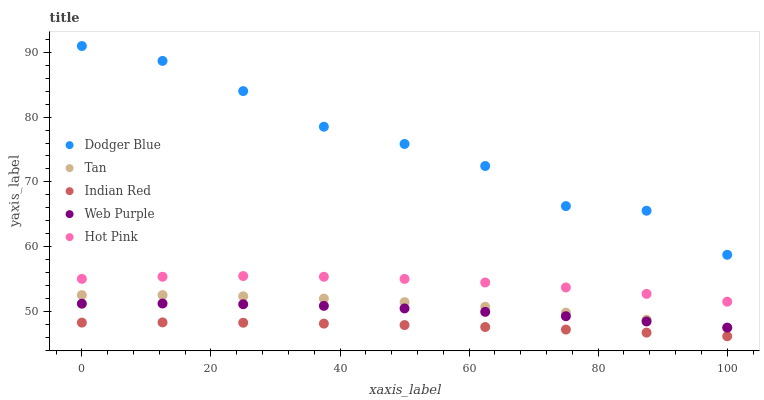Does Indian Red have the minimum area under the curve?
Answer yes or no. Yes. Does Dodger Blue have the maximum area under the curve?
Answer yes or no. Yes. Does Hot Pink have the minimum area under the curve?
Answer yes or no. No. Does Hot Pink have the maximum area under the curve?
Answer yes or no. No. Is Indian Red the smoothest?
Answer yes or no. Yes. Is Dodger Blue the roughest?
Answer yes or no. Yes. Is Hot Pink the smoothest?
Answer yes or no. No. Is Hot Pink the roughest?
Answer yes or no. No. Does Indian Red have the lowest value?
Answer yes or no. Yes. Does Hot Pink have the lowest value?
Answer yes or no. No. Does Dodger Blue have the highest value?
Answer yes or no. Yes. Does Hot Pink have the highest value?
Answer yes or no. No. Is Indian Red less than Hot Pink?
Answer yes or no. Yes. Is Dodger Blue greater than Indian Red?
Answer yes or no. Yes. Does Tan intersect Web Purple?
Answer yes or no. Yes. Is Tan less than Web Purple?
Answer yes or no. No. Is Tan greater than Web Purple?
Answer yes or no. No. Does Indian Red intersect Hot Pink?
Answer yes or no. No. 